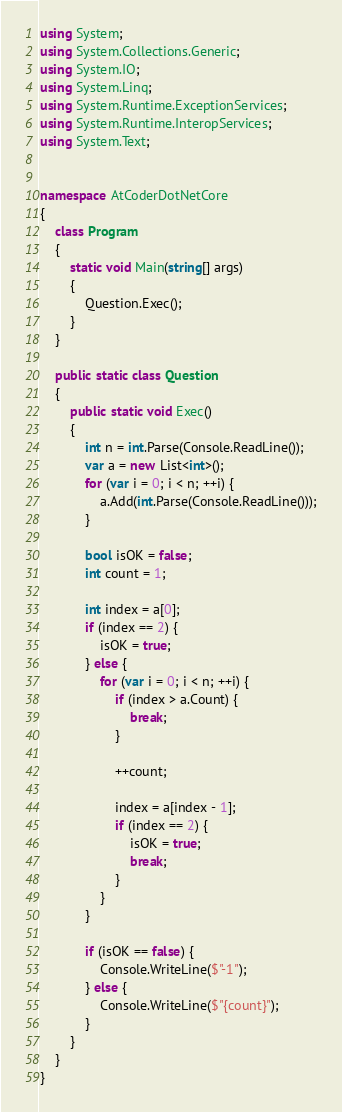<code> <loc_0><loc_0><loc_500><loc_500><_C#_>using System;
using System.Collections.Generic;
using System.IO;
using System.Linq;
using System.Runtime.ExceptionServices;
using System.Runtime.InteropServices;
using System.Text;


namespace AtCoderDotNetCore
{
	class Program
	{
		static void Main(string[] args)
		{
			Question.Exec();
		}
	}

	public static class Question
	{
		public static void Exec()
		{
			int n = int.Parse(Console.ReadLine());
			var a = new List<int>();
			for (var i = 0; i < n; ++i) {
				a.Add(int.Parse(Console.ReadLine()));
			}

			bool isOK = false;
			int count = 1;

			int index = a[0];
			if (index == 2) {
				isOK = true;
			} else {
				for (var i = 0; i < n; ++i) {
					if (index > a.Count) {
						break;
					}

					++count;

					index = a[index - 1];
					if (index == 2) {
						isOK = true;
						break;
					}
				}
			}

			if (isOK == false) {
				Console.WriteLine($"-1");
			} else {
				Console.WriteLine($"{count}");
			}
		}
	}
}</code> 